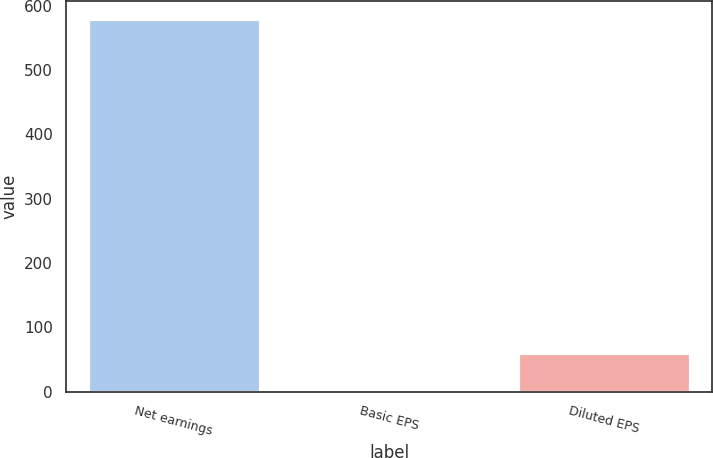Convert chart. <chart><loc_0><loc_0><loc_500><loc_500><bar_chart><fcel>Net earnings<fcel>Basic EPS<fcel>Diluted EPS<nl><fcel>578.6<fcel>2.01<fcel>59.67<nl></chart> 